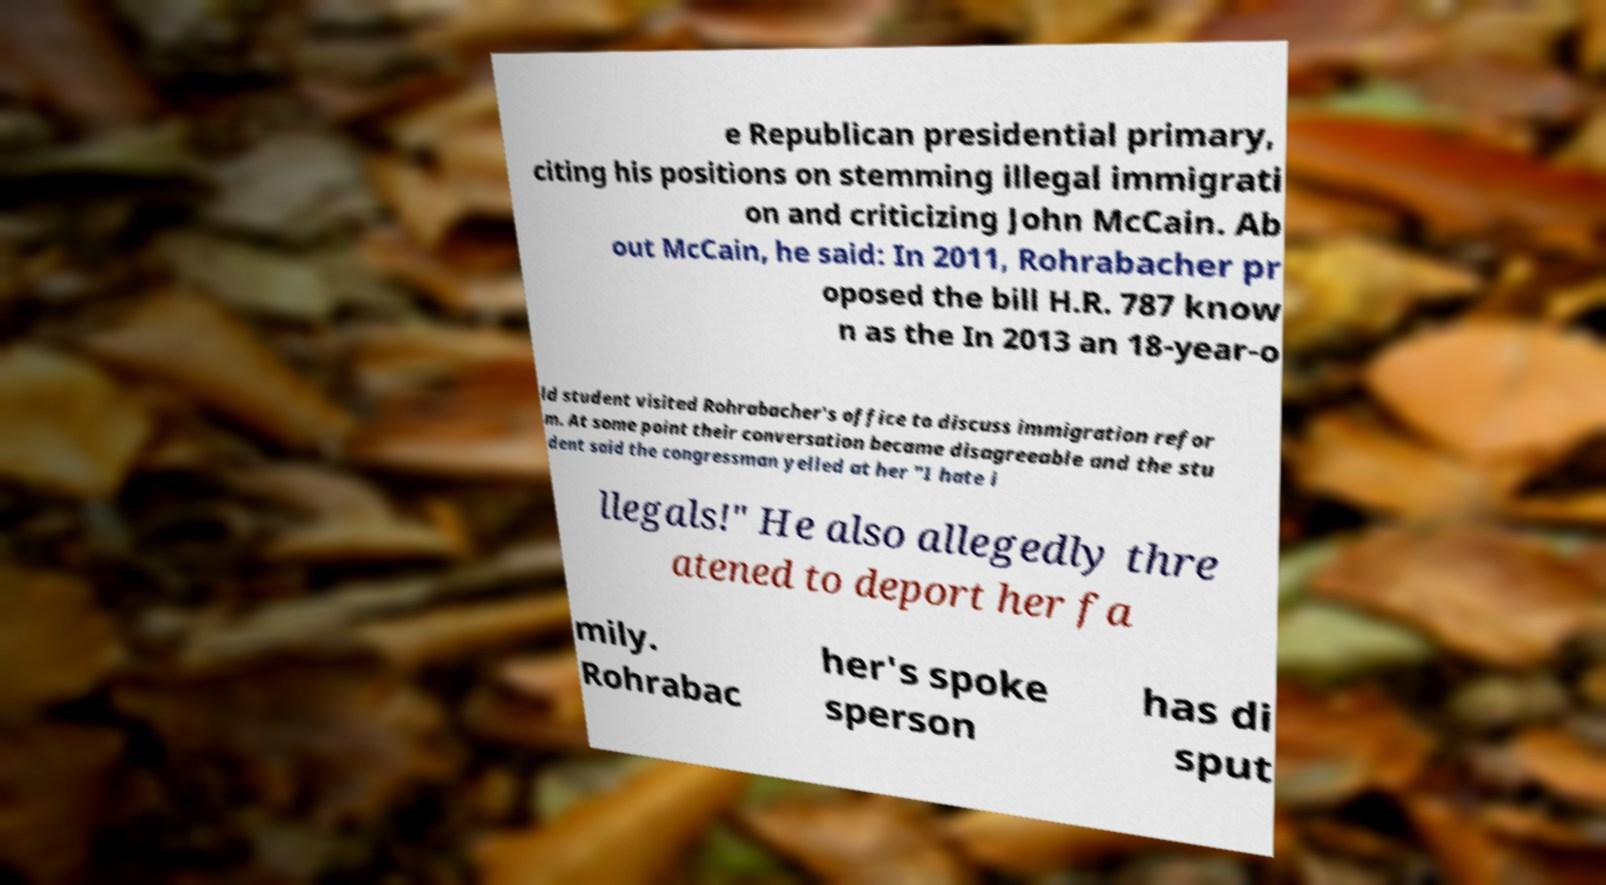For documentation purposes, I need the text within this image transcribed. Could you provide that? e Republican presidential primary, citing his positions on stemming illegal immigrati on and criticizing John McCain. Ab out McCain, he said: In 2011, Rohrabacher pr oposed the bill H.R. 787 know n as the In 2013 an 18-year-o ld student visited Rohrabacher's office to discuss immigration refor m. At some point their conversation became disagreeable and the stu dent said the congressman yelled at her "I hate i llegals!" He also allegedly thre atened to deport her fa mily. Rohrabac her's spoke sperson has di sput 